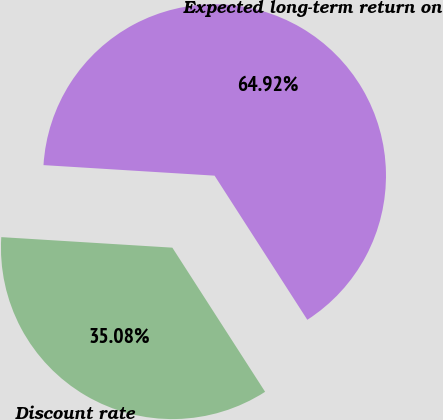Convert chart. <chart><loc_0><loc_0><loc_500><loc_500><pie_chart><fcel>Discount rate<fcel>Expected long-term return on<nl><fcel>35.08%<fcel>64.92%<nl></chart> 